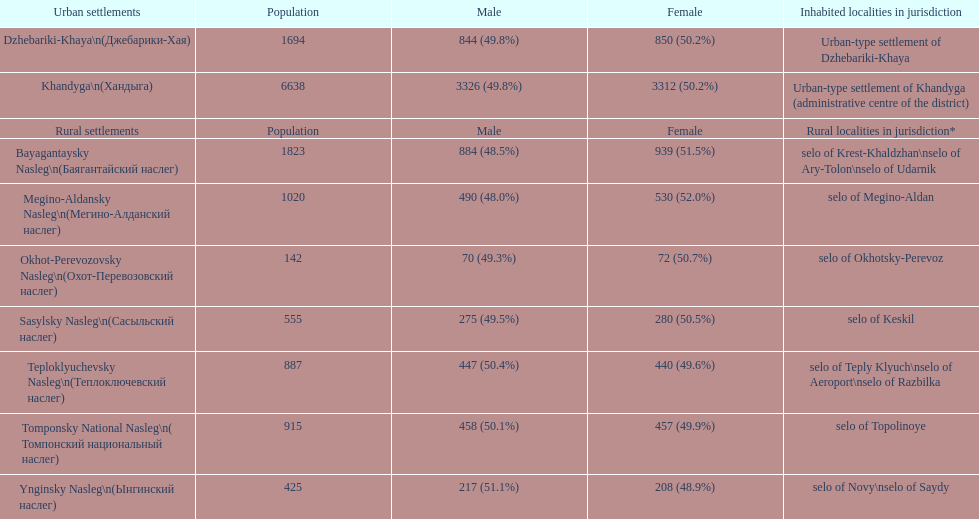Parse the table in full. {'header': ['Urban settlements', 'Population', 'Male', 'Female', 'Inhabited localities in jurisdiction'], 'rows': [['Dzhebariki-Khaya\\n(Джебарики-Хая)', '1694', '844 (49.8%)', '850 (50.2%)', 'Urban-type settlement of Dzhebariki-Khaya'], ['Khandyga\\n(Хандыга)', '6638', '3326 (49.8%)', '3312 (50.2%)', 'Urban-type settlement of Khandyga (administrative centre of the district)'], ['Rural settlements', 'Population', 'Male', 'Female', 'Rural localities in jurisdiction*'], ['Bayagantaysky Nasleg\\n(Баягантайский наслег)', '1823', '884 (48.5%)', '939 (51.5%)', 'selo of Krest-Khaldzhan\\nselo of Ary-Tolon\\nselo of Udarnik'], ['Megino-Aldansky Nasleg\\n(Мегино-Алданский наслег)', '1020', '490 (48.0%)', '530 (52.0%)', 'selo of Megino-Aldan'], ['Okhot-Perevozovsky Nasleg\\n(Охот-Перевозовский наслег)', '142', '70 (49.3%)', '72 (50.7%)', 'selo of Okhotsky-Perevoz'], ['Sasylsky Nasleg\\n(Сасыльский наслег)', '555', '275 (49.5%)', '280 (50.5%)', 'selo of Keskil'], ['Teploklyuchevsky Nasleg\\n(Теплоключевский наслег)', '887', '447 (50.4%)', '440 (49.6%)', 'selo of Teply Klyuch\\nselo of Aeroport\\nselo of Razbilka'], ['Tomponsky National Nasleg\\n( Томпонский национальный наслег)', '915', '458 (50.1%)', '457 (49.9%)', 'selo of Topolinoye'], ['Ynginsky Nasleg\\n(Ынгинский наслег)', '425', '217 (51.1%)', '208 (48.9%)', 'selo of Novy\\nselo of Saydy']]} Which rural settlement has the most males in their population? Bayagantaysky Nasleg (Áàÿãàíòàéñêèé íàñëåã). 